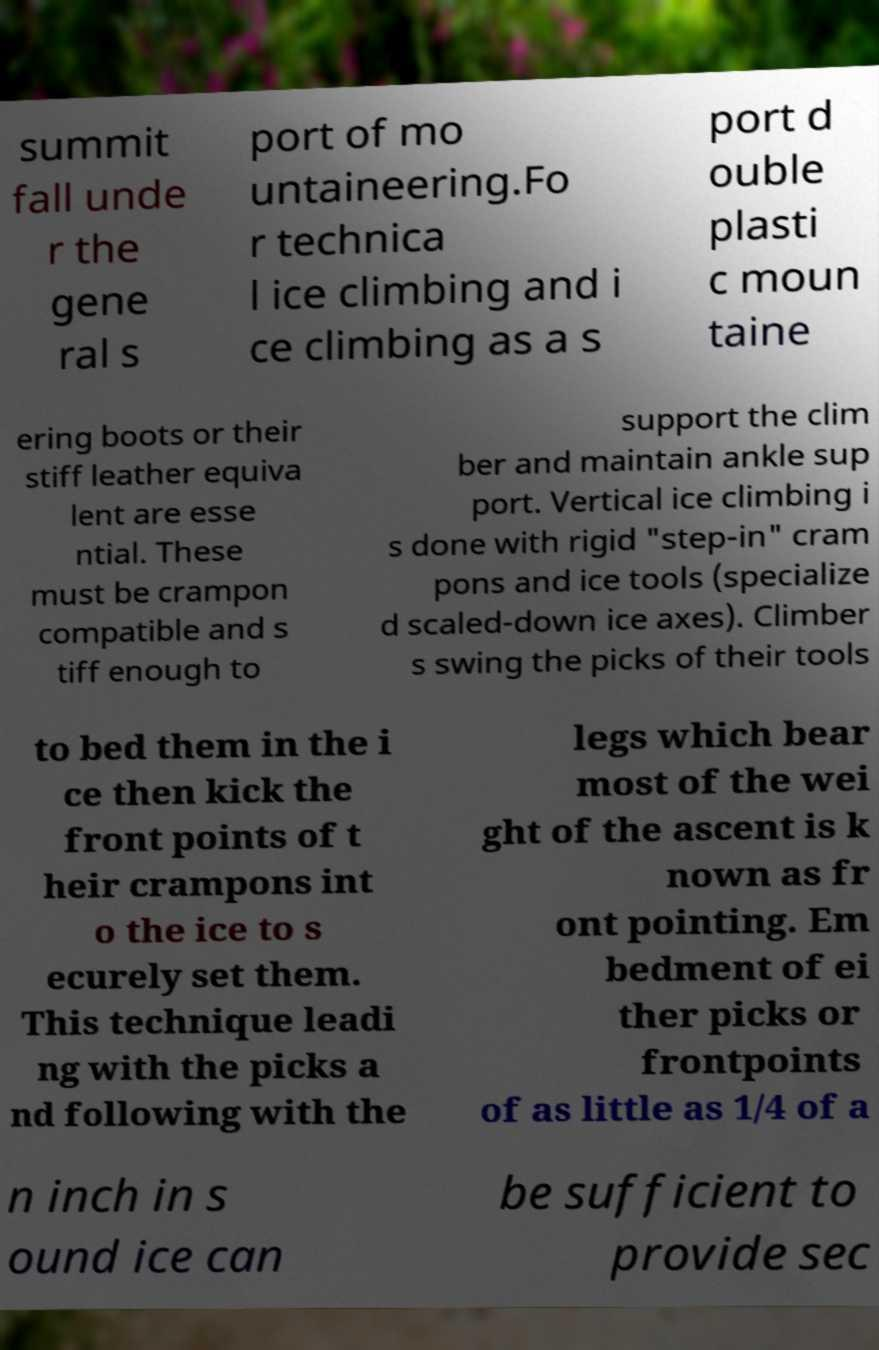What messages or text are displayed in this image? I need them in a readable, typed format. summit fall unde r the gene ral s port of mo untaineering.Fo r technica l ice climbing and i ce climbing as a s port d ouble plasti c moun taine ering boots or their stiff leather equiva lent are esse ntial. These must be crampon compatible and s tiff enough to support the clim ber and maintain ankle sup port. Vertical ice climbing i s done with rigid "step-in" cram pons and ice tools (specialize d scaled-down ice axes). Climber s swing the picks of their tools to bed them in the i ce then kick the front points of t heir crampons int o the ice to s ecurely set them. This technique leadi ng with the picks a nd following with the legs which bear most of the wei ght of the ascent is k nown as fr ont pointing. Em bedment of ei ther picks or frontpoints of as little as 1/4 of a n inch in s ound ice can be sufficient to provide sec 